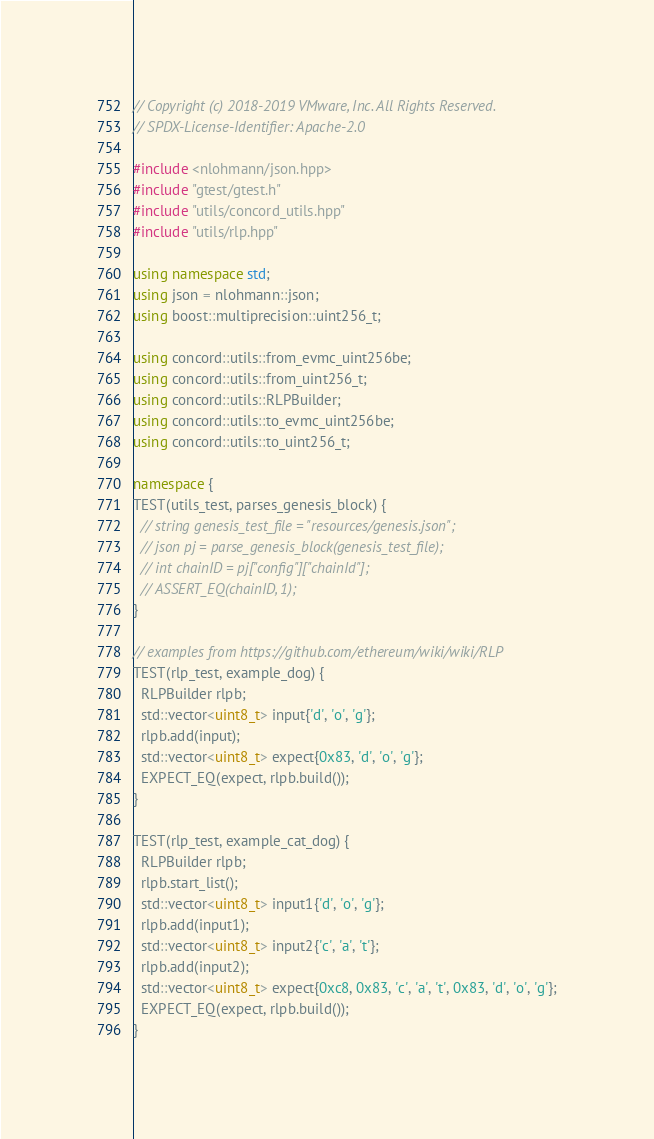Convert code to text. <code><loc_0><loc_0><loc_500><loc_500><_C++_>// Copyright (c) 2018-2019 VMware, Inc. All Rights Reserved.
// SPDX-License-Identifier: Apache-2.0

#include <nlohmann/json.hpp>
#include "gtest/gtest.h"
#include "utils/concord_utils.hpp"
#include "utils/rlp.hpp"

using namespace std;
using json = nlohmann::json;
using boost::multiprecision::uint256_t;

using concord::utils::from_evmc_uint256be;
using concord::utils::from_uint256_t;
using concord::utils::RLPBuilder;
using concord::utils::to_evmc_uint256be;
using concord::utils::to_uint256_t;

namespace {
TEST(utils_test, parses_genesis_block) {
  // string genesis_test_file = "resources/genesis.json";
  // json pj = parse_genesis_block(genesis_test_file);
  // int chainID = pj["config"]["chainId"];
  // ASSERT_EQ(chainID, 1);
}

// examples from https://github.com/ethereum/wiki/wiki/RLP
TEST(rlp_test, example_dog) {
  RLPBuilder rlpb;
  std::vector<uint8_t> input{'d', 'o', 'g'};
  rlpb.add(input);
  std::vector<uint8_t> expect{0x83, 'd', 'o', 'g'};
  EXPECT_EQ(expect, rlpb.build());
}

TEST(rlp_test, example_cat_dog) {
  RLPBuilder rlpb;
  rlpb.start_list();
  std::vector<uint8_t> input1{'d', 'o', 'g'};
  rlpb.add(input1);
  std::vector<uint8_t> input2{'c', 'a', 't'};
  rlpb.add(input2);
  std::vector<uint8_t> expect{0xc8, 0x83, 'c', 'a', 't', 0x83, 'd', 'o', 'g'};
  EXPECT_EQ(expect, rlpb.build());
}
</code> 